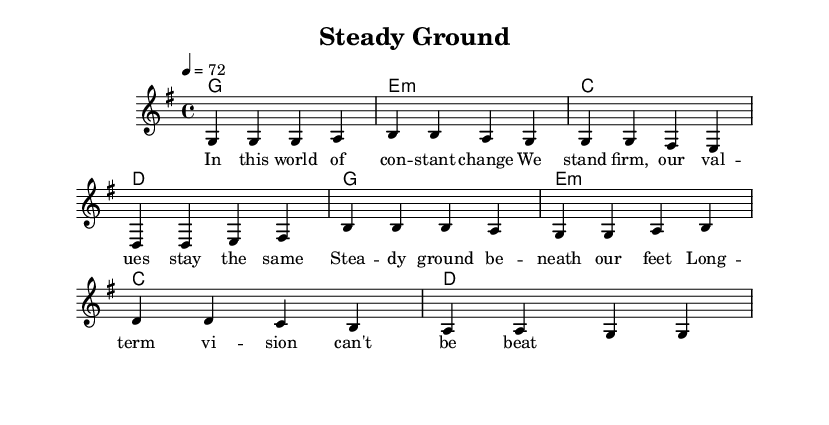What is the key signature of this music? The key signature is G major, which has one sharp (F#). This can be identified by looking at the key signature symbol at the beginning of the staff.
Answer: G major What is the time signature of this piece? The time signature is 4/4, indicated by the symbol that appears at the beginning of the music. This means there are four quarter note beats in each measure.
Answer: 4/4 What is the tempo marking of the music? The tempo marking is quarter note equals 72, which indicates the speed at which the piece should be played. This is noted at the beginning of the score.
Answer: 72 How many measures are in the song's chorus? The chorus consists of four measures as indicated by counting the grouped notes in the section labeled for the chorus.
Answer: 4 What chord follows the G major chord in the progression? After the G major chord, the progression goes to E minor, which is the next chord indicated in the harmonies section. This is confirmed by analyzing the chord symbols written above the melody.
Answer: E minor What themes are expressed in the lyrics of the first verse? The lyrics of the first verse express themes of stability and the importance of consistent values in a changing world, as evidenced by the words chosen to depict these ideas.
Answer: Stability How does the chorus relate to the overall message of the song? The chorus emphasizes the idea of having a long-term vision and being on steady ground, reinforcing the message of commitment and stability, which is a common theme in reggae music.
Answer: Long-term vision 